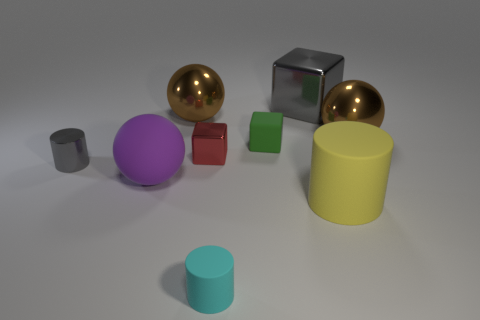Is the number of big blocks in front of the metal cylinder greater than the number of metal objects that are to the left of the tiny green rubber object?
Your answer should be compact. No. What number of spheres are either tiny cyan matte things or tiny rubber things?
Your response must be concise. 0. Is there any other thing that has the same size as the shiny cylinder?
Make the answer very short. Yes. Do the big gray object that is on the right side of the gray cylinder and the large purple thing have the same shape?
Your response must be concise. No. What color is the big cube?
Your answer should be compact. Gray. There is another metallic thing that is the same shape as the small cyan object; what color is it?
Keep it short and to the point. Gray. How many large purple things are the same shape as the large yellow matte thing?
Give a very brief answer. 0. How many objects are either tiny red metal blocks or big things that are in front of the large purple rubber thing?
Offer a very short reply. 2. Do the tiny metal cylinder and the metallic block that is right of the cyan cylinder have the same color?
Offer a very short reply. Yes. What is the size of the cylinder that is to the left of the gray block and behind the small cyan rubber cylinder?
Give a very brief answer. Small. 